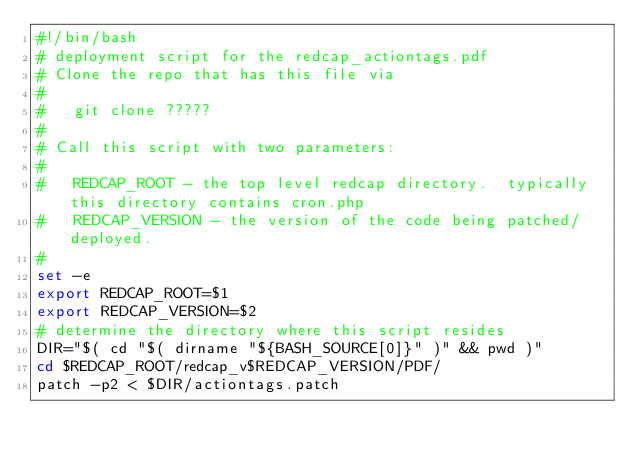<code> <loc_0><loc_0><loc_500><loc_500><_Bash_>#!/bin/bash
# deployment script for the redcap_actiontags.pdf 
# Clone the repo that has this file via
#
#   git clone ?????
#
# Call this script with two parameters:
#
#   REDCAP_ROOT - the top level redcap directory.  typically this directory contains cron.php
#   REDCAP_VERSION - the version of the code being patched/deployed.
#
set -e
export REDCAP_ROOT=$1
export REDCAP_VERSION=$2
# determine the directory where this script resides
DIR="$( cd "$( dirname "${BASH_SOURCE[0]}" )" && pwd )"
cd $REDCAP_ROOT/redcap_v$REDCAP_VERSION/PDF/
patch -p2 < $DIR/actiontags.patch
</code> 